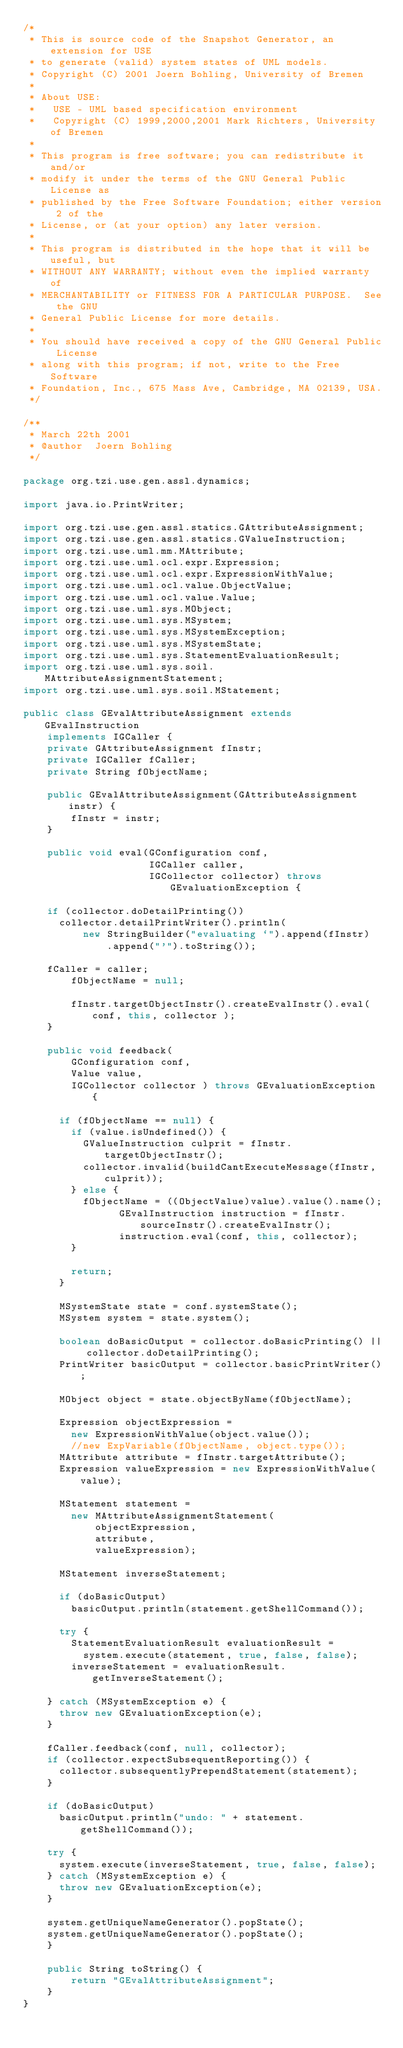Convert code to text. <code><loc_0><loc_0><loc_500><loc_500><_Java_>/*
 * This is source code of the Snapshot Generator, an extension for USE
 * to generate (valid) system states of UML models.
 * Copyright (C) 2001 Joern Bohling, University of Bremen
 *
 * About USE:
 *   USE - UML based specification environment
 *   Copyright (C) 1999,2000,2001 Mark Richters, University of Bremen
 *
 * This program is free software; you can redistribute it and/or
 * modify it under the terms of the GNU General Public License as
 * published by the Free Software Foundation; either version 2 of the
 * License, or (at your option) any later version.
 *
 * This program is distributed in the hope that it will be useful, but
 * WITHOUT ANY WARRANTY; without even the implied warranty of
 * MERCHANTABILITY or FITNESS FOR A PARTICULAR PURPOSE.  See the GNU
 * General Public License for more details.
 *
 * You should have received a copy of the GNU General Public License
 * along with this program; if not, write to the Free Software
 * Foundation, Inc., 675 Mass Ave, Cambridge, MA 02139, USA.
 */

/**
 * March 22th 2001 
 * @author  Joern Bohling
 */

package org.tzi.use.gen.assl.dynamics;

import java.io.PrintWriter;

import org.tzi.use.gen.assl.statics.GAttributeAssignment;
import org.tzi.use.gen.assl.statics.GValueInstruction;
import org.tzi.use.uml.mm.MAttribute;
import org.tzi.use.uml.ocl.expr.Expression;
import org.tzi.use.uml.ocl.expr.ExpressionWithValue;
import org.tzi.use.uml.ocl.value.ObjectValue;
import org.tzi.use.uml.ocl.value.Value;
import org.tzi.use.uml.sys.MObject;
import org.tzi.use.uml.sys.MSystem;
import org.tzi.use.uml.sys.MSystemException;
import org.tzi.use.uml.sys.MSystemState;
import org.tzi.use.uml.sys.StatementEvaluationResult;
import org.tzi.use.uml.sys.soil.MAttributeAssignmentStatement;
import org.tzi.use.uml.sys.soil.MStatement;

public class GEvalAttributeAssignment extends GEvalInstruction
    implements IGCaller {
    private GAttributeAssignment fInstr;
    private IGCaller fCaller;
    private String fObjectName;

    public GEvalAttributeAssignment(GAttributeAssignment instr) {
        fInstr = instr;
    }

    public void eval(GConfiguration conf,
                     IGCaller caller,
                     IGCollector collector) throws GEvaluationException {

		if (collector.doDetailPrinting())
			collector.detailPrintWriter().println(
					new StringBuilder("evaluating `").append(fInstr)
							.append("'").toString());
        
		fCaller = caller;
        fObjectName = null;
        
        fInstr.targetObjectInstr().createEvalInstr().eval( conf, this, collector );
    }

    public void feedback(
    		GConfiguration conf, 
    		Value value, 
    		IGCollector collector ) throws GEvaluationException {
        
    	if (fObjectName == null) {
    		if (value.isUndefined()) {   			
    			GValueInstruction culprit = fInstr.targetObjectInstr();
    			collector.invalid(buildCantExecuteMessage(fInstr, culprit));
    		} else {
    			fObjectName = ((ObjectValue)value).value().name();
                GEvalInstruction instruction = fInstr.sourceInstr().createEvalInstr();
                instruction.eval(conf, this, collector);
    		}
    		
    		return;
    	}
    	
    	MSystemState state = conf.systemState();
    	MSystem system = state.system();
    	
    	boolean doBasicOutput = collector.doBasicPrinting() || collector.doDetailPrinting();
    	PrintWriter basicOutput = collector.basicPrintWriter();
    	
    	MObject object = state.objectByName(fObjectName);
    	
    	Expression objectExpression = 
    		new ExpressionWithValue(object.value());
    		//new ExpVariable(fObjectName, object.type());
    	MAttribute attribute = fInstr.targetAttribute();
    	Expression valueExpression = new ExpressionWithValue(value);
    	
    	MStatement statement = 
    		new MAttributeAssignmentStatement(
    				objectExpression, 
    				attribute, 
    				valueExpression);
    	
    	MStatement inverseStatement;
    	
    	if (doBasicOutput)
    		basicOutput.println(statement.getShellCommand());
    	
    	try {
    		StatementEvaluationResult evaluationResult = 
    			system.execute(statement, true, false, false);
    		inverseStatement = evaluationResult.getInverseStatement();
    		
		} catch (MSystemException e) {
			throw new GEvaluationException(e);
		}
		
		fCaller.feedback(conf, null, collector);
		if (collector.expectSubsequentReporting()) {
			collector.subsequentlyPrependStatement(statement);
		}
        
		if (doBasicOutput)
			basicOutput.println("undo: " + statement.getShellCommand());
		
		try {
			system.execute(inverseStatement, true, false, false);
		} catch (MSystemException e) {
			throw new GEvaluationException(e);
		}
		
		system.getUniqueNameGenerator().popState();
		system.getUniqueNameGenerator().popState();
    }

    public String toString() {
        return "GEvalAttributeAssignment";
    }
}
</code> 